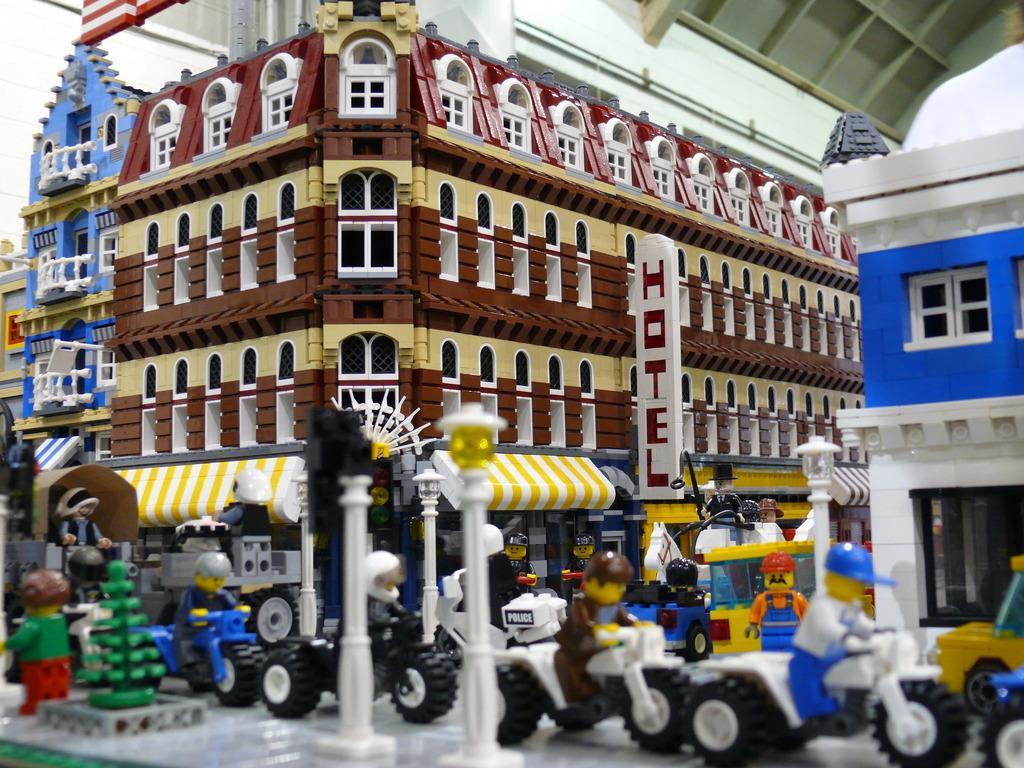In one or two sentences, can you explain what this image depicts? In this image we can see depictions of buildings, vehicles and peoples. 